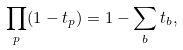<formula> <loc_0><loc_0><loc_500><loc_500>\prod _ { p } ( 1 - t _ { p } ) = 1 - \sum _ { b } t _ { b } ,</formula> 